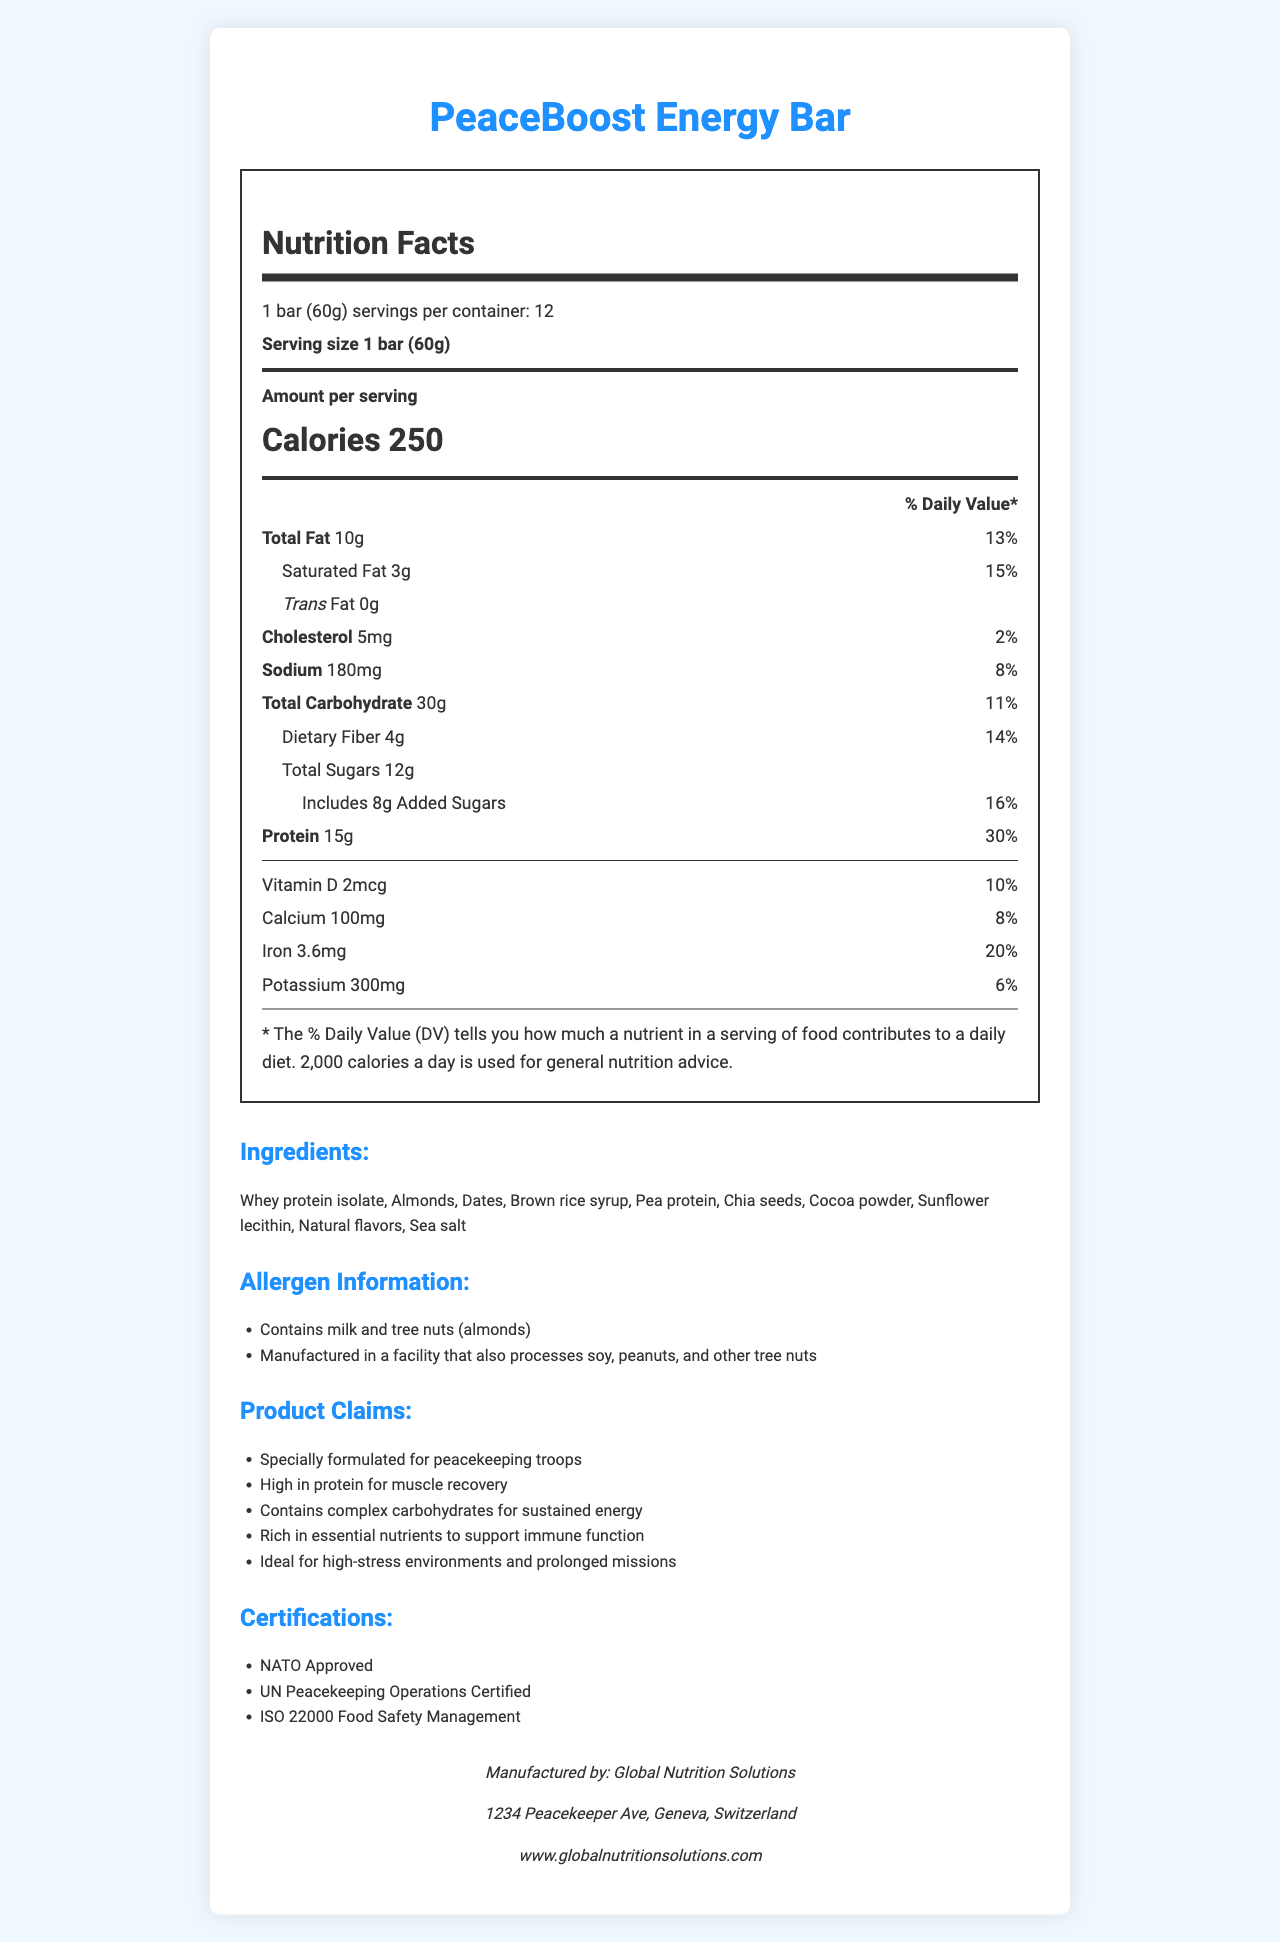how many servings are in one container of PeaceBoost Energy Bar? The document states that there are 12 servings per container.
Answer: 12 how many calories are there per serving of the PeaceBoost Energy Bar? The document specifies that there are 250 calories per serving.
Answer: 250 list three main claims made about the PeaceBoost Energy Bar. These claims are listed under the "Product Claims" section of the document.
Answer: 1. High in protein for muscle recovery, 2. Contains complex carbohydrates for sustained energy, 3. Rich in essential nutrients to support immune function what is the amount of protein in each serving of the PeaceBoost Energy Bar? The Nutrition Facts section indicates that there are 15 grams of protein per serving.
Answer: 15g identify two ingredients that are sources of protein in the PeaceBoost Energy Bar. These ingredients are listed in the "Ingredients" section and are known sources of protein.
Answer: Whey protein isolate, Pea protein what percentage of the daily value of saturated fat does one serving of the PeaceBoost Energy Bar provide? The Nutrition Facts section shows that one serving provides 15% of the daily value for saturated fat.
Answer: 15% what are the main allergens present in the PeaceBoost Energy Bar? The allergen information clearly states that the product contains milk and tree nuts (almonds).
Answer: Contains milk and tree nuts (almonds) how many grams of dietary fiber are in each serving of the PeaceBoost Energy Bar? The Nutrition Facts section indicates that one serving contains 4 grams of dietary fiber.
Answer: 4g which of the following is NOT an ingredient in the PeaceBoost Energy Bar? A. Whey protein isolate B. Honey C. Cocoa powder D. Chia seeds Honey is not listed as an ingredient; the other options are.
Answer: B. Honey what certifications does the PeaceBoost Energy Bar have? The document lists these certifications under the "Certifications" section.
Answer: NATO Approved, UN Peacekeeping Operations Certified, ISO 22000 Food Safety Management how much sodium is in one serving of the PeaceBoost Energy Bar? The Nutrition Facts section indicates that one serving contains 180 milligrams of sodium.
Answer: 180mg which ingredient contributes to the PeaceBoost Energy Bar's source of complex carbohydrates? A. Dates B. Pea protein C. Brown rice syrup D. Sunflower lecithin Brown rice syrup is known for being a source of complex carbohydrates, while the other options are not primarily for carbohydrates.
Answer: C. Brown rice syrup is the PeaceBoost Energy Bar suitable for someone with a peanut allergy? The allergen information mentions that the product is manufactured in a facility that also processes peanuts, which may not be suitable for those with a peanut allergy.
Answer: No describe the main nutritional benefits of the PeaceBoost Energy Bar. The document highlights these features in the nutrition facts, ingredient list, and claim statements.
Answer: The PeaceBoost Energy Bar is designed to provide an energy boost, with 250 calories per serving, 15g of protein for muscle recovery, 4g of dietary fiber for digestive health, and essential nutrients like calcium, iron, and vitamin D to support overall wellbeing. It contains complex carbohydrates for sustained energy and is ideal for high-stress environments and prolonged missions. who manufactures the PeaceBoost Energy Bar? This information can be found under the "Manufacturer" section.
Answer: Global Nutrition Solutions cannot determine if the PeaceBoost Energy Bar is gluten-free based on the document. The document does not provide information about gluten content or related ingredients.
Answer: Not enough information 